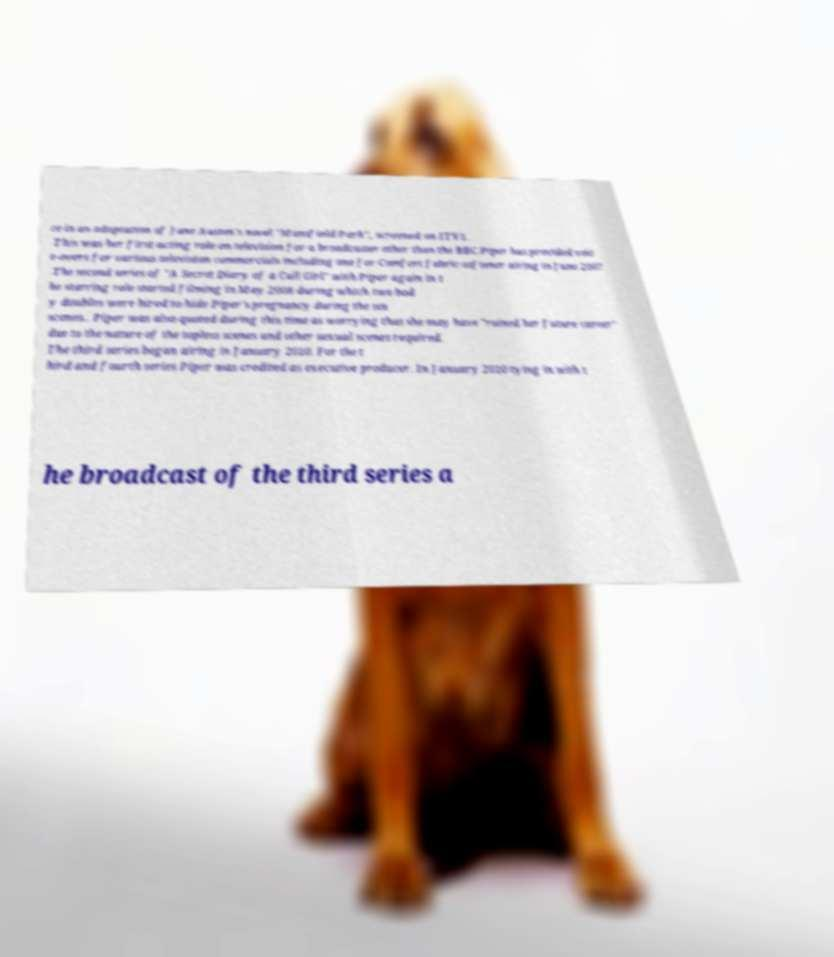I need the written content from this picture converted into text. Can you do that? ce in an adaptation of Jane Austen's novel "Mansfield Park", screened on ITV1. This was her first acting role on television for a broadcaster other than the BBC.Piper has provided voic e-overs for various television commercials including one for Comfort fabric-softener airing in June 2007 .The second series of "A Secret Diary of a Call Girl" with Piper again in t he starring role started filming in May 2008 during which two bod y doubles were hired to hide Piper's pregnancy during the sex scenes.. Piper was also quoted during this time as worrying that she may have "ruined her future career" due to the nature of the topless scenes and other sexual scenes required. The third series began airing in January 2010. For the t hird and fourth series Piper was credited as executive producer. In January 2010 tying in with t he broadcast of the third series a 